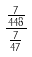<formula> <loc_0><loc_0><loc_500><loc_500>\frac { \frac { 7 } { 4 4 8 } } { \frac { 7 } { 4 7 } }</formula> 